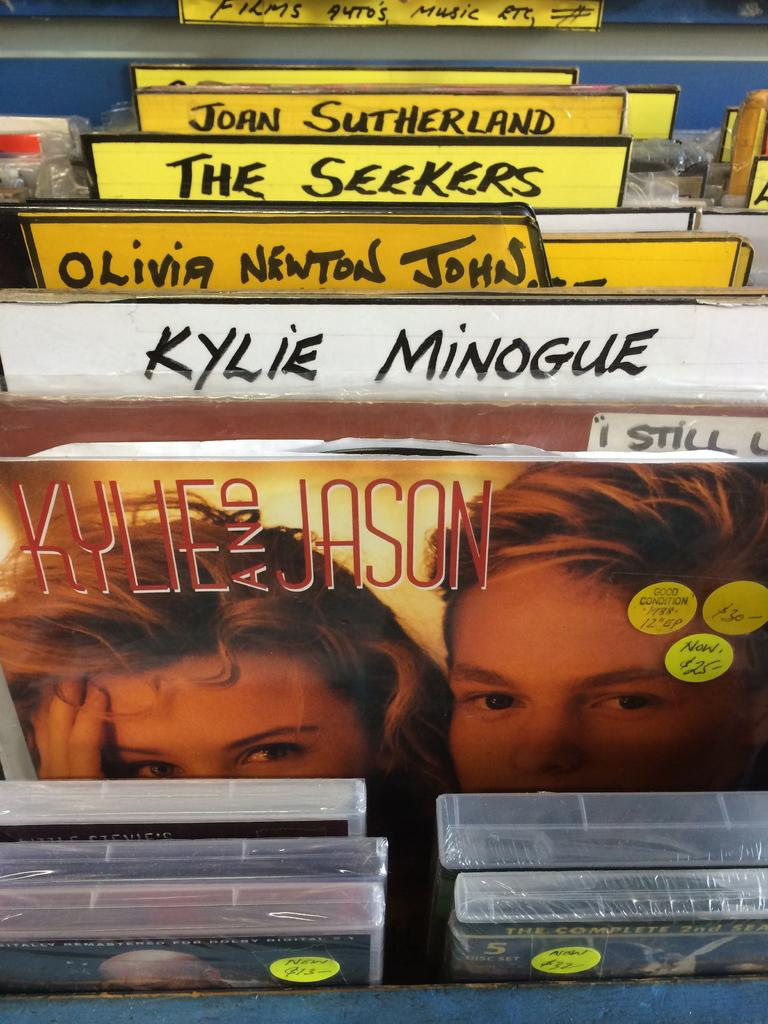What type of storage device is shown in the image? There are DVD trays in the image. What is the condition of the DVD trays? The DVD trays are packed. What else can be seen in the image besides the DVD trays? There is a poster and name boards in the image. How many dimes are placed on top of the DVD trays in the image? There are no dimes present in the image. What is the income of the person who owns the DVD trays in the image? The income of the person who owns the DVD trays cannot be determined from the image. 